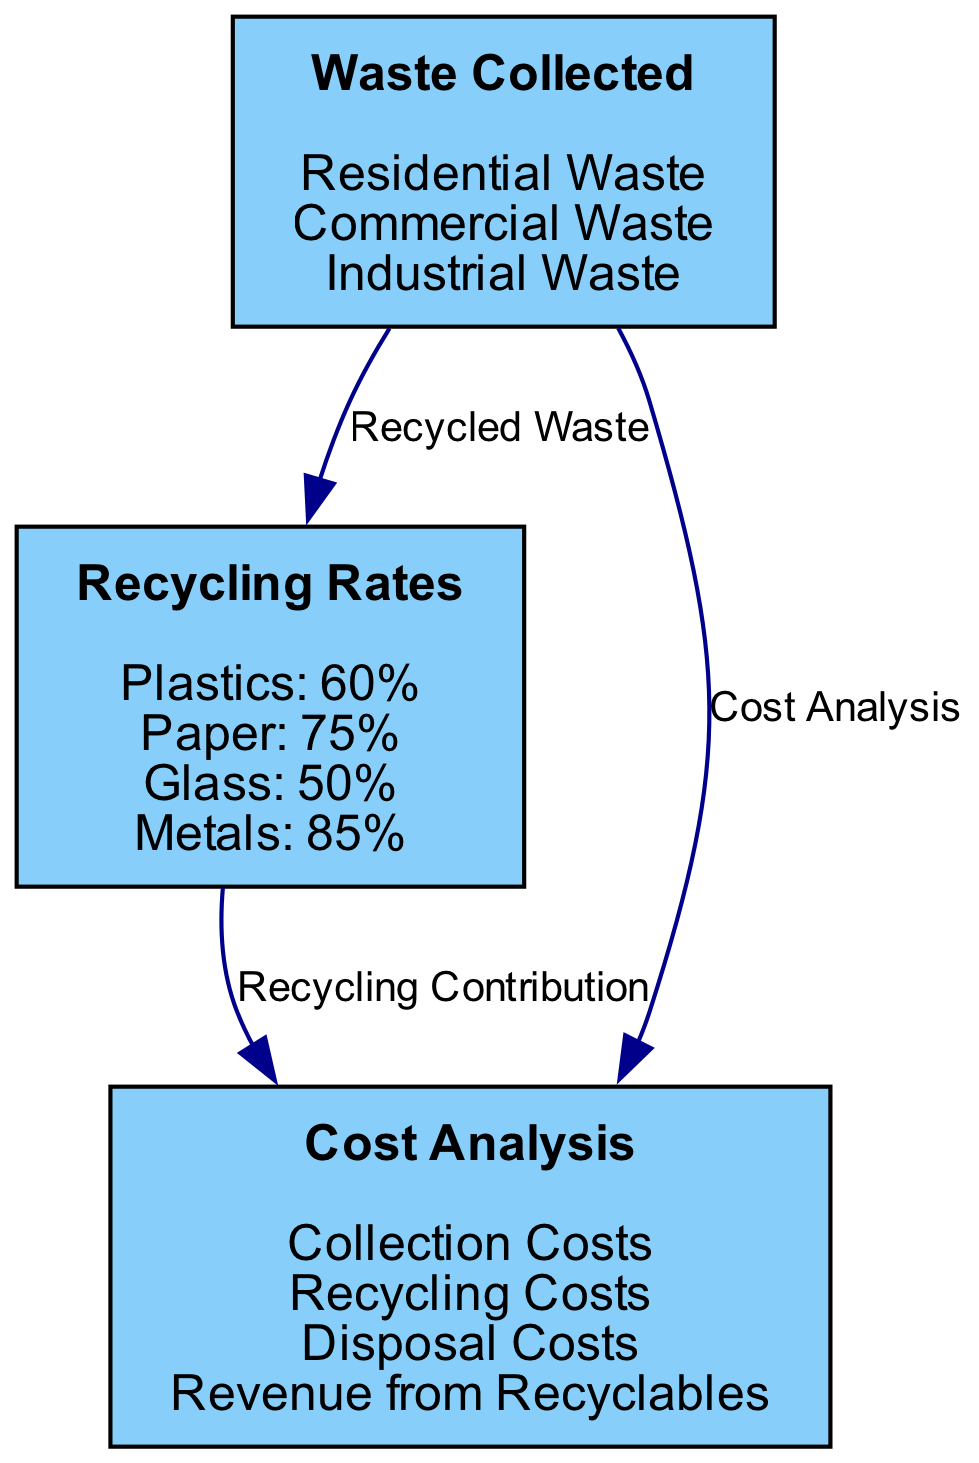What are the categories of waste collected? The diagram lists three categories of waste collected: Residential Waste, Commercial Waste, and Industrial Waste. These are shown directly under the "Waste Collected" node.
Answer: Residential Waste, Commercial Waste, Industrial Waste What is the recycling rate for plastics? The recycling rate for plastics is indicated as 60% in the "Recycling Rates" section of the diagram.
Answer: 60% How many nodes are in the diagram? The diagram includes three nodes: Waste Collected, Recycling Rates, and Cost Analysis. This can be counted directly by identifying each distinct category.
Answer: 3 What is the edge label connecting Waste Collected to Cost Analysis? The edge label connecting these two nodes is "Cost Analysis," as specified by the diagram.
Answer: Cost Analysis What is the recycling rate for metals? The recycling rate for metals is listed as 85% in the "Recycling Rates" section of the diagram.
Answer: 85% How does the recycling rate for paper relate to the overall cost analysis? The diagram indicates a relationship through the edge labeled "Recycling Contribution", connecting the Recycling Rates to Cost Analysis. This means that recycling rates can impact financial aspects associated with waste management.
Answer: Recycling Contribution What types of costs are included in the Cost Analysis node? The Cost Analysis category includes Collection Costs, Recycling Costs, Disposal Costs, and Revenue from Recyclables, explicitly listed under this node in the diagram.
Answer: Collection Costs, Recycling Costs, Disposal Costs, Revenue from Recyclables Which type of waste contributes the most to recycling rates? The diagram does not explicitly quantify contributions per waste type, but it shows connections indicating that each waste type ultimately feeds into the recycling rates. Thus, one would need to analyze the individual recycling rates to determine contributions.
Answer: Indeterminate How is residential waste related to recycling rates? Residential waste appears under the Waste Collected node, which has an edge labeled "Recycled Waste" going to Recycling Rates. This indicates that residential waste is part of the recycling process affected by the rates detailed in the Recycling Rates node.
Answer: Recycled Waste 